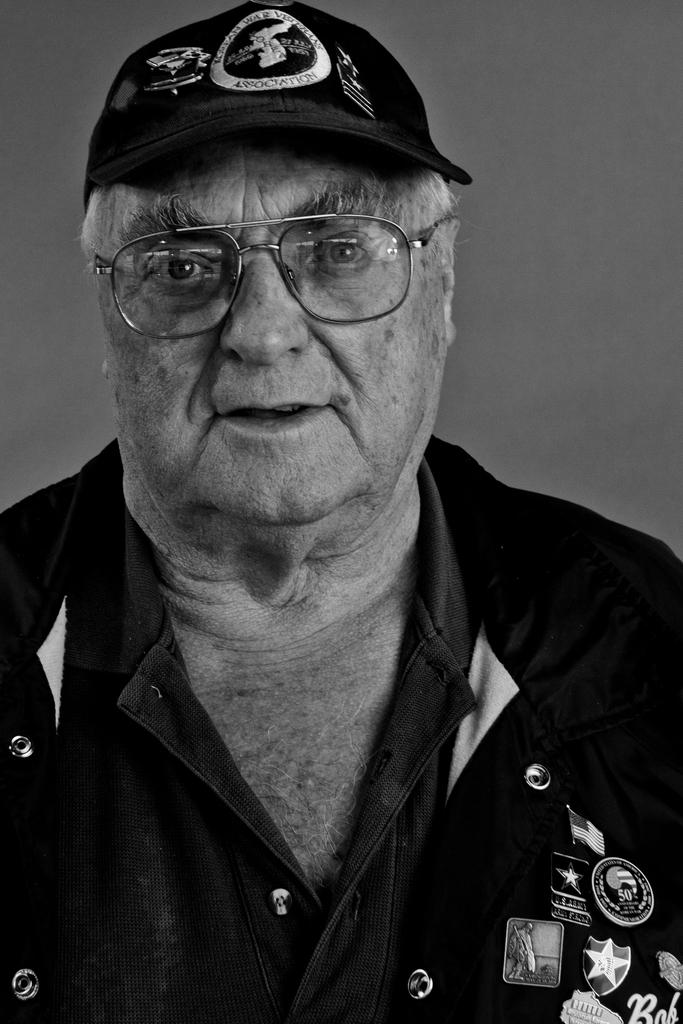What is the main subject of the image? The main subject of the image is a man. What is the man wearing on his upper body? The man is wearing a black shirt. What type of headwear is the man wearing? The man is wearing a black cap. What is the color of the background in the image? The background of the image is gray in color. What type of thought is the man having in the image? There is no indication of the man's thoughts in the image. What type of insurance policy is the man holding in the image? There is no insurance policy present in the image. What type of yoke is the man using to control an animal in the image? There is no yoke or animal present in the image. 